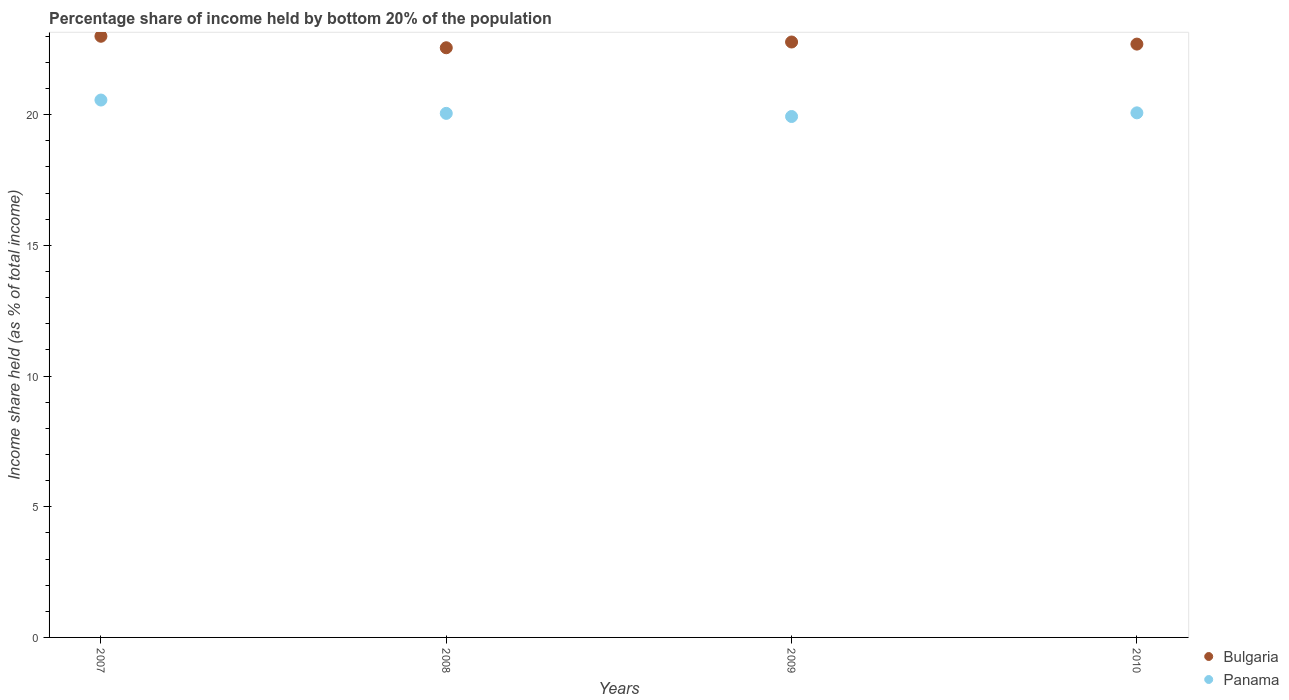How many different coloured dotlines are there?
Give a very brief answer. 2. What is the share of income held by bottom 20% of the population in Panama in 2007?
Your answer should be compact. 20.56. Across all years, what is the maximum share of income held by bottom 20% of the population in Bulgaria?
Make the answer very short. 23. Across all years, what is the minimum share of income held by bottom 20% of the population in Bulgaria?
Provide a short and direct response. 22.56. In which year was the share of income held by bottom 20% of the population in Panama maximum?
Ensure brevity in your answer.  2007. What is the total share of income held by bottom 20% of the population in Bulgaria in the graph?
Offer a terse response. 91.04. What is the difference between the share of income held by bottom 20% of the population in Bulgaria in 2009 and that in 2010?
Provide a succinct answer. 0.08. What is the difference between the share of income held by bottom 20% of the population in Panama in 2008 and the share of income held by bottom 20% of the population in Bulgaria in 2009?
Offer a terse response. -2.73. What is the average share of income held by bottom 20% of the population in Panama per year?
Provide a succinct answer. 20.15. In the year 2009, what is the difference between the share of income held by bottom 20% of the population in Bulgaria and share of income held by bottom 20% of the population in Panama?
Your answer should be very brief. 2.85. What is the ratio of the share of income held by bottom 20% of the population in Panama in 2008 to that in 2010?
Make the answer very short. 1. Is the share of income held by bottom 20% of the population in Bulgaria in 2007 less than that in 2009?
Keep it short and to the point. No. What is the difference between the highest and the second highest share of income held by bottom 20% of the population in Panama?
Offer a very short reply. 0.49. What is the difference between the highest and the lowest share of income held by bottom 20% of the population in Bulgaria?
Ensure brevity in your answer.  0.44. Is the sum of the share of income held by bottom 20% of the population in Bulgaria in 2009 and 2010 greater than the maximum share of income held by bottom 20% of the population in Panama across all years?
Give a very brief answer. Yes. Is the share of income held by bottom 20% of the population in Panama strictly greater than the share of income held by bottom 20% of the population in Bulgaria over the years?
Give a very brief answer. No. Is the share of income held by bottom 20% of the population in Bulgaria strictly less than the share of income held by bottom 20% of the population in Panama over the years?
Give a very brief answer. No. How many years are there in the graph?
Keep it short and to the point. 4. Does the graph contain grids?
Your answer should be compact. No. Where does the legend appear in the graph?
Offer a very short reply. Bottom right. How are the legend labels stacked?
Offer a terse response. Vertical. What is the title of the graph?
Make the answer very short. Percentage share of income held by bottom 20% of the population. Does "Tunisia" appear as one of the legend labels in the graph?
Your response must be concise. No. What is the label or title of the Y-axis?
Provide a succinct answer. Income share held (as % of total income). What is the Income share held (as % of total income) of Panama in 2007?
Your answer should be very brief. 20.56. What is the Income share held (as % of total income) in Bulgaria in 2008?
Make the answer very short. 22.56. What is the Income share held (as % of total income) in Panama in 2008?
Your answer should be very brief. 20.05. What is the Income share held (as % of total income) of Bulgaria in 2009?
Ensure brevity in your answer.  22.78. What is the Income share held (as % of total income) in Panama in 2009?
Your answer should be very brief. 19.93. What is the Income share held (as % of total income) of Bulgaria in 2010?
Your answer should be compact. 22.7. What is the Income share held (as % of total income) of Panama in 2010?
Offer a terse response. 20.07. Across all years, what is the maximum Income share held (as % of total income) in Panama?
Your response must be concise. 20.56. Across all years, what is the minimum Income share held (as % of total income) in Bulgaria?
Keep it short and to the point. 22.56. Across all years, what is the minimum Income share held (as % of total income) of Panama?
Keep it short and to the point. 19.93. What is the total Income share held (as % of total income) of Bulgaria in the graph?
Your response must be concise. 91.04. What is the total Income share held (as % of total income) in Panama in the graph?
Provide a succinct answer. 80.61. What is the difference between the Income share held (as % of total income) in Bulgaria in 2007 and that in 2008?
Ensure brevity in your answer.  0.44. What is the difference between the Income share held (as % of total income) in Panama in 2007 and that in 2008?
Ensure brevity in your answer.  0.51. What is the difference between the Income share held (as % of total income) of Bulgaria in 2007 and that in 2009?
Your answer should be very brief. 0.22. What is the difference between the Income share held (as % of total income) in Panama in 2007 and that in 2009?
Offer a terse response. 0.63. What is the difference between the Income share held (as % of total income) in Panama in 2007 and that in 2010?
Your answer should be very brief. 0.49. What is the difference between the Income share held (as % of total income) of Bulgaria in 2008 and that in 2009?
Offer a very short reply. -0.22. What is the difference between the Income share held (as % of total income) of Panama in 2008 and that in 2009?
Make the answer very short. 0.12. What is the difference between the Income share held (as % of total income) of Bulgaria in 2008 and that in 2010?
Provide a short and direct response. -0.14. What is the difference between the Income share held (as % of total income) of Panama in 2008 and that in 2010?
Your answer should be very brief. -0.02. What is the difference between the Income share held (as % of total income) in Panama in 2009 and that in 2010?
Keep it short and to the point. -0.14. What is the difference between the Income share held (as % of total income) in Bulgaria in 2007 and the Income share held (as % of total income) in Panama in 2008?
Offer a very short reply. 2.95. What is the difference between the Income share held (as % of total income) in Bulgaria in 2007 and the Income share held (as % of total income) in Panama in 2009?
Provide a succinct answer. 3.07. What is the difference between the Income share held (as % of total income) of Bulgaria in 2007 and the Income share held (as % of total income) of Panama in 2010?
Your response must be concise. 2.93. What is the difference between the Income share held (as % of total income) of Bulgaria in 2008 and the Income share held (as % of total income) of Panama in 2009?
Provide a short and direct response. 2.63. What is the difference between the Income share held (as % of total income) in Bulgaria in 2008 and the Income share held (as % of total income) in Panama in 2010?
Keep it short and to the point. 2.49. What is the difference between the Income share held (as % of total income) in Bulgaria in 2009 and the Income share held (as % of total income) in Panama in 2010?
Give a very brief answer. 2.71. What is the average Income share held (as % of total income) in Bulgaria per year?
Your answer should be compact. 22.76. What is the average Income share held (as % of total income) of Panama per year?
Offer a terse response. 20.15. In the year 2007, what is the difference between the Income share held (as % of total income) in Bulgaria and Income share held (as % of total income) in Panama?
Your answer should be compact. 2.44. In the year 2008, what is the difference between the Income share held (as % of total income) in Bulgaria and Income share held (as % of total income) in Panama?
Provide a succinct answer. 2.51. In the year 2009, what is the difference between the Income share held (as % of total income) of Bulgaria and Income share held (as % of total income) of Panama?
Your response must be concise. 2.85. In the year 2010, what is the difference between the Income share held (as % of total income) in Bulgaria and Income share held (as % of total income) in Panama?
Provide a succinct answer. 2.63. What is the ratio of the Income share held (as % of total income) of Bulgaria in 2007 to that in 2008?
Your response must be concise. 1.02. What is the ratio of the Income share held (as % of total income) in Panama in 2007 to that in 2008?
Your response must be concise. 1.03. What is the ratio of the Income share held (as % of total income) of Bulgaria in 2007 to that in 2009?
Make the answer very short. 1.01. What is the ratio of the Income share held (as % of total income) of Panama in 2007 to that in 2009?
Make the answer very short. 1.03. What is the ratio of the Income share held (as % of total income) in Bulgaria in 2007 to that in 2010?
Provide a succinct answer. 1.01. What is the ratio of the Income share held (as % of total income) in Panama in 2007 to that in 2010?
Your answer should be very brief. 1.02. What is the ratio of the Income share held (as % of total income) in Bulgaria in 2008 to that in 2009?
Provide a succinct answer. 0.99. What is the ratio of the Income share held (as % of total income) in Panama in 2009 to that in 2010?
Your answer should be very brief. 0.99. What is the difference between the highest and the second highest Income share held (as % of total income) in Bulgaria?
Make the answer very short. 0.22. What is the difference between the highest and the second highest Income share held (as % of total income) in Panama?
Offer a terse response. 0.49. What is the difference between the highest and the lowest Income share held (as % of total income) in Bulgaria?
Your answer should be very brief. 0.44. What is the difference between the highest and the lowest Income share held (as % of total income) of Panama?
Your answer should be very brief. 0.63. 